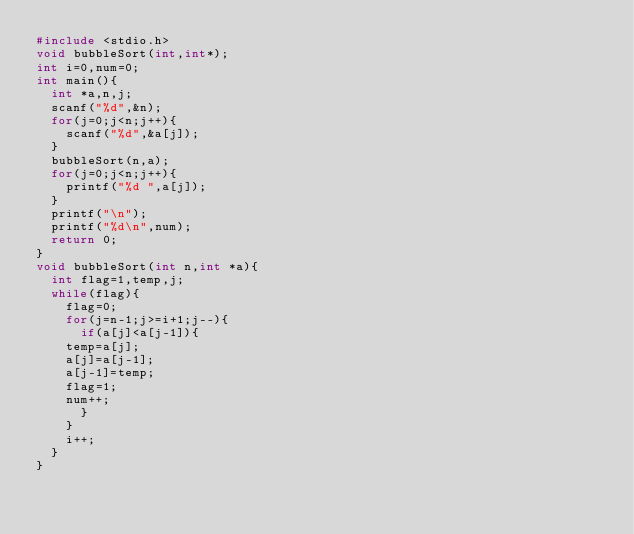Convert code to text. <code><loc_0><loc_0><loc_500><loc_500><_C_>#include <stdio.h>
void bubbleSort(int,int*);
int i=0,num=0;
int main(){
  int *a,n,j;
  scanf("%d",&n);
  for(j=0;j<n;j++){
    scanf("%d",&a[j]);
  }
  bubbleSort(n,a);
  for(j=0;j<n;j++){
    printf("%d ",a[j]);
  }
  printf("\n");
  printf("%d\n",num);
  return 0;
}
void bubbleSort(int n,int *a){
  int flag=1,temp,j;
  while(flag){
    flag=0;
    for(j=n-1;j>=i+1;j--){
      if(a[j]<a[j-1]){
	temp=a[j];
	a[j]=a[j-1];
	a[j-1]=temp;
	flag=1;
	num++;
      }
    }
    i++;
  }
}</code> 